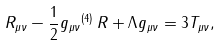Convert formula to latex. <formula><loc_0><loc_0><loc_500><loc_500>R _ { \mu \nu } - \frac { 1 } { 2 } g _ { \mu \nu } { ^ { ( 4 ) } \, } R + \Lambda g _ { \mu \nu } = 3 T _ { \mu \nu } ,</formula> 